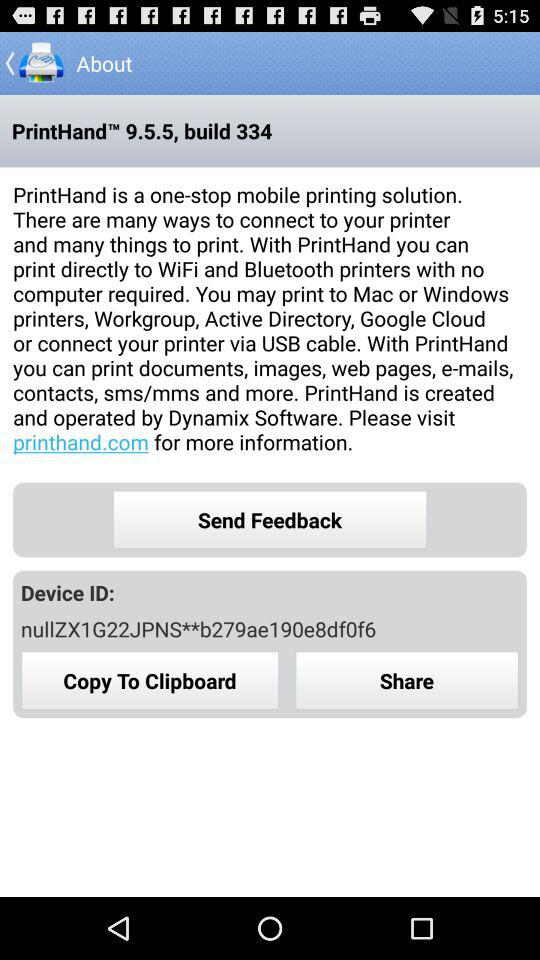What is the device ID? The device ID is nullZX1G22JPNS**b279ae190e8df0f6. 